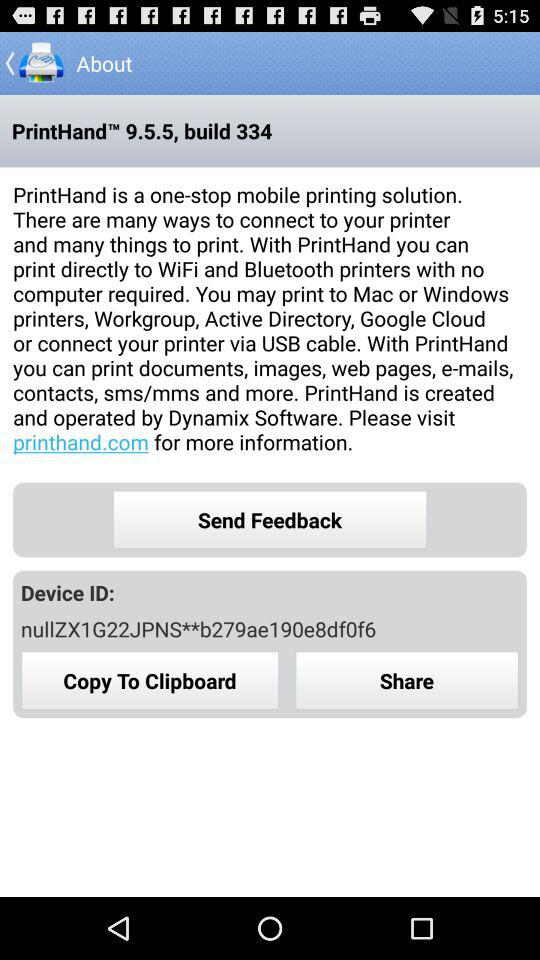What is the device ID? The device ID is nullZX1G22JPNS**b279ae190e8df0f6. 